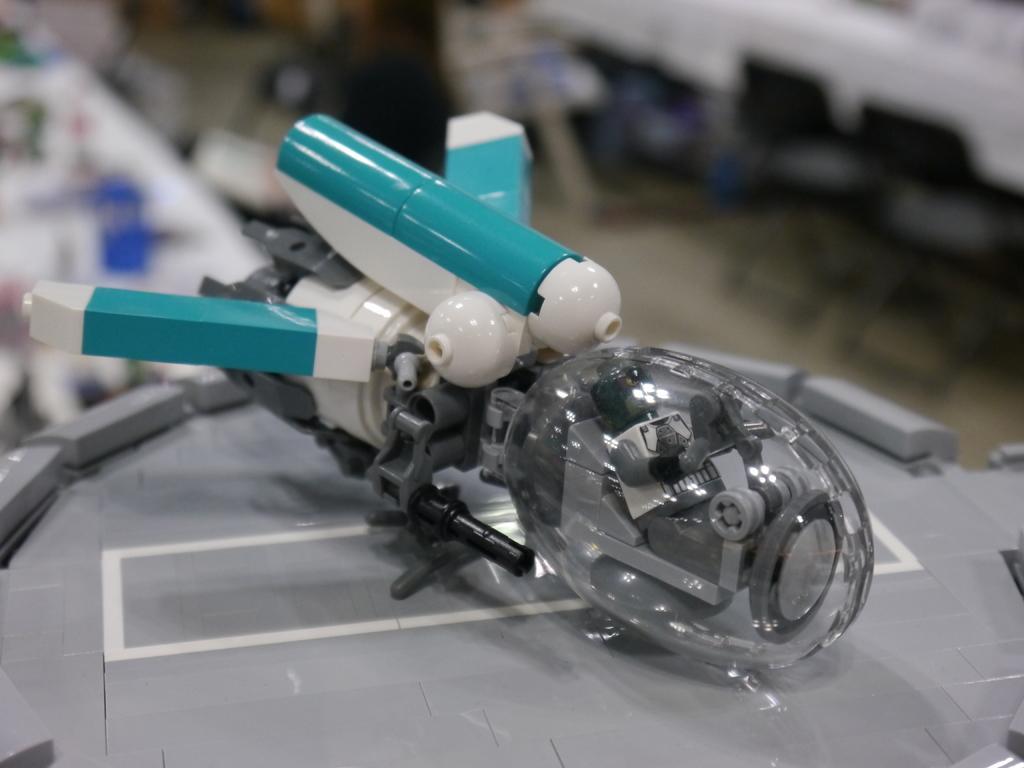Can you describe this image briefly? In the center of the image we can see you placed on the table. 